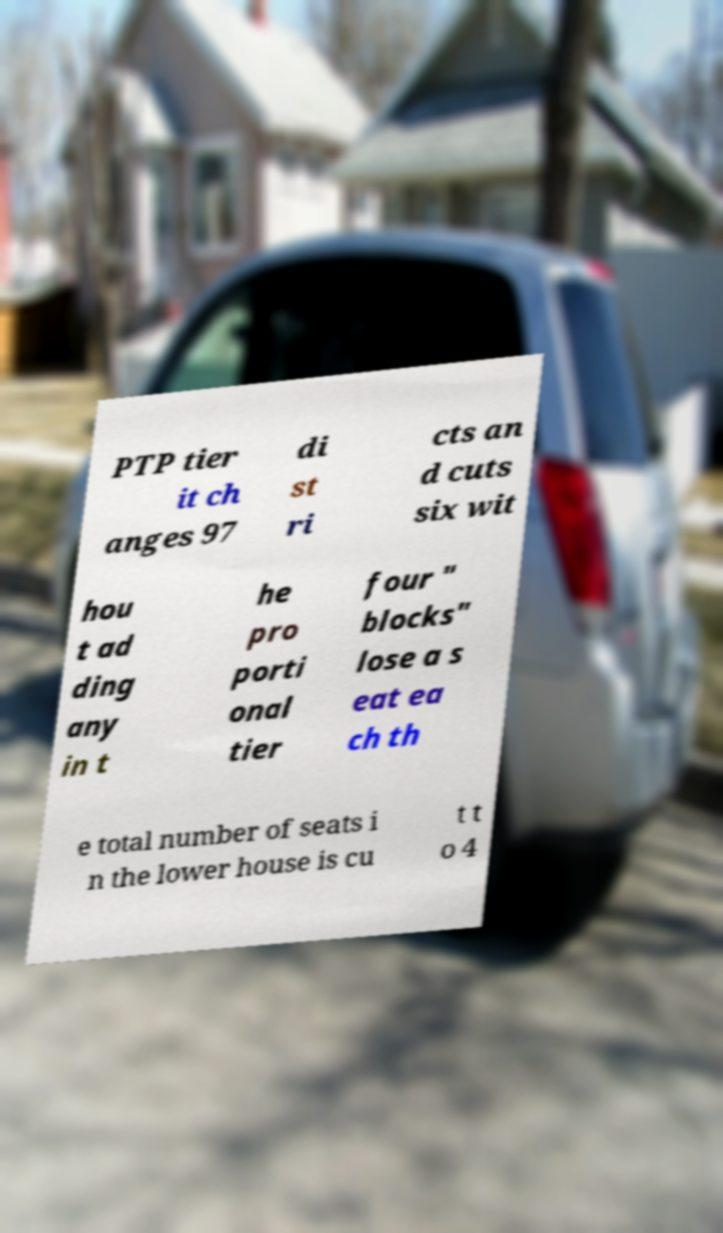There's text embedded in this image that I need extracted. Can you transcribe it verbatim? PTP tier it ch anges 97 di st ri cts an d cuts six wit hou t ad ding any in t he pro porti onal tier four " blocks" lose a s eat ea ch th e total number of seats i n the lower house is cu t t o 4 